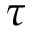<formula> <loc_0><loc_0><loc_500><loc_500>\tau</formula> 